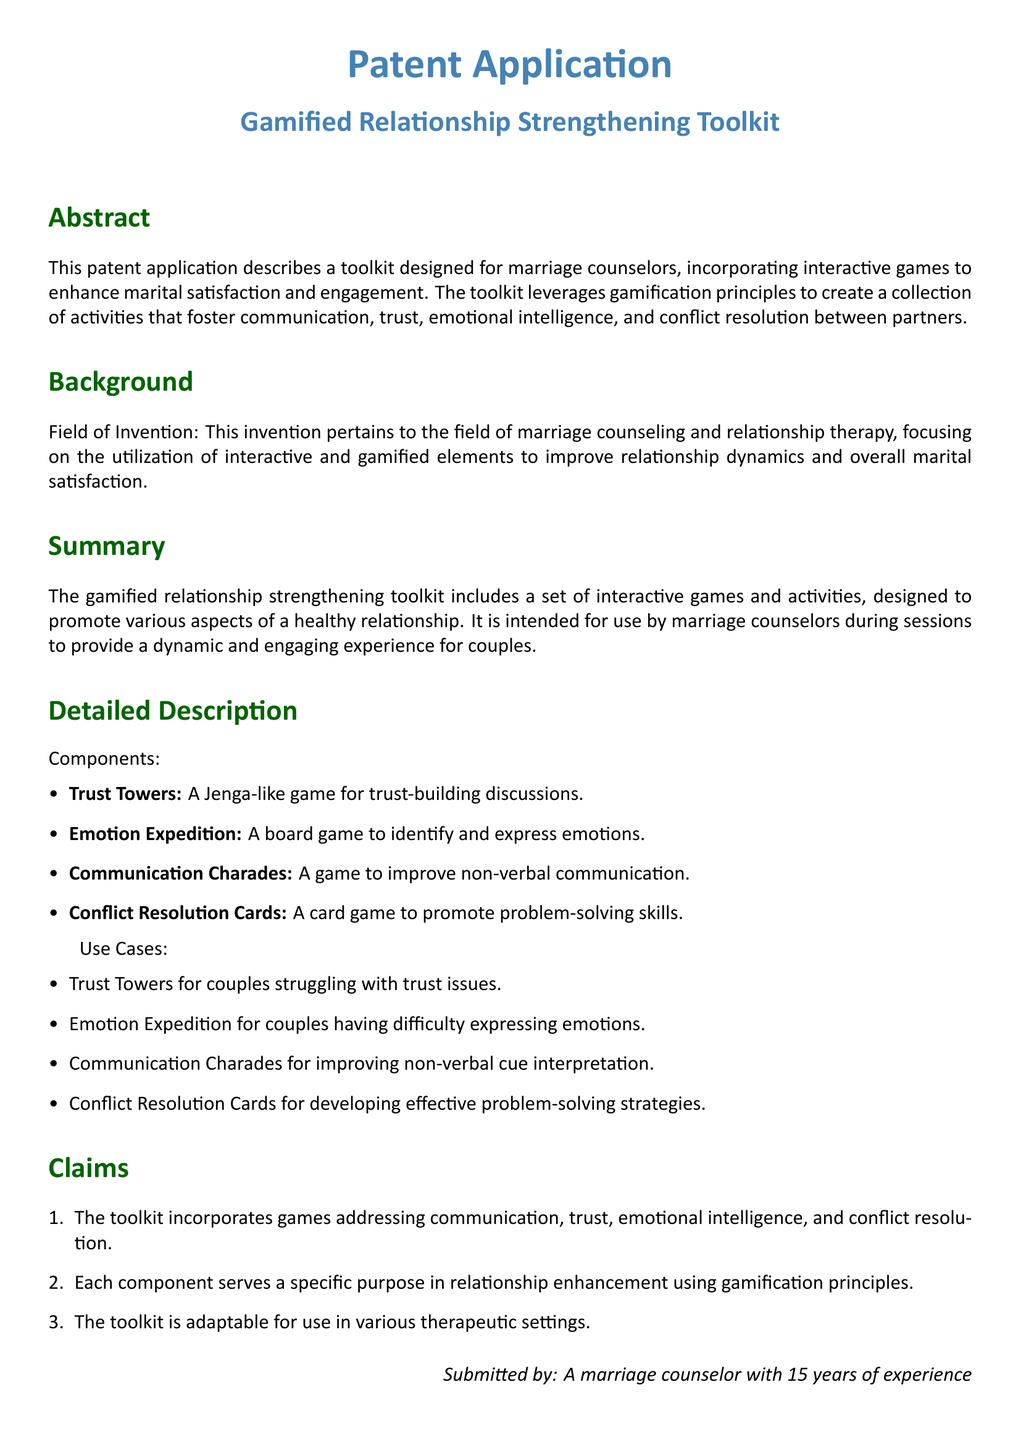What is the title of the patent application? The title is mentioned in the document heading, specifically in the first section.
Answer: Gamified Relationship Strengthening Toolkit What is the primary purpose of the toolkit? The purpose is outlined in the abstract, focusing on enhancing marital satisfaction and engagement.
Answer: To improve marital satisfaction and engagement What is one component of the toolkit? The components are explicitly listed in the detailed description section.
Answer: Trust Towers How many claims are made in the patent application? The number of claims is presented in the claims section of the document.
Answer: Three What game is designed for trust-building discussions? The specific game dedicated to trust-building is mentioned in the detailed description.
Answer: Trust Towers Which game helps identify and express emotions? The game focused on emotions is included in the list of components of the toolkit.
Answer: Emotion Expedition What is the field of invention according to the background section? The field of invention is stated in the background description.
Answer: Marriage counseling What type of therapeutic settings can the toolkit be adapted for? The adaptability of the toolkit is highlighted in the claims section.
Answer: Various therapeutic settings What type of game is Communication Charades? This game type is specifically categorized in the detailed description.
Answer: Non-verbal communication Who submitted the patent application? The submission details are found at the end of the document.
Answer: A marriage counselor with 15 years of experience 